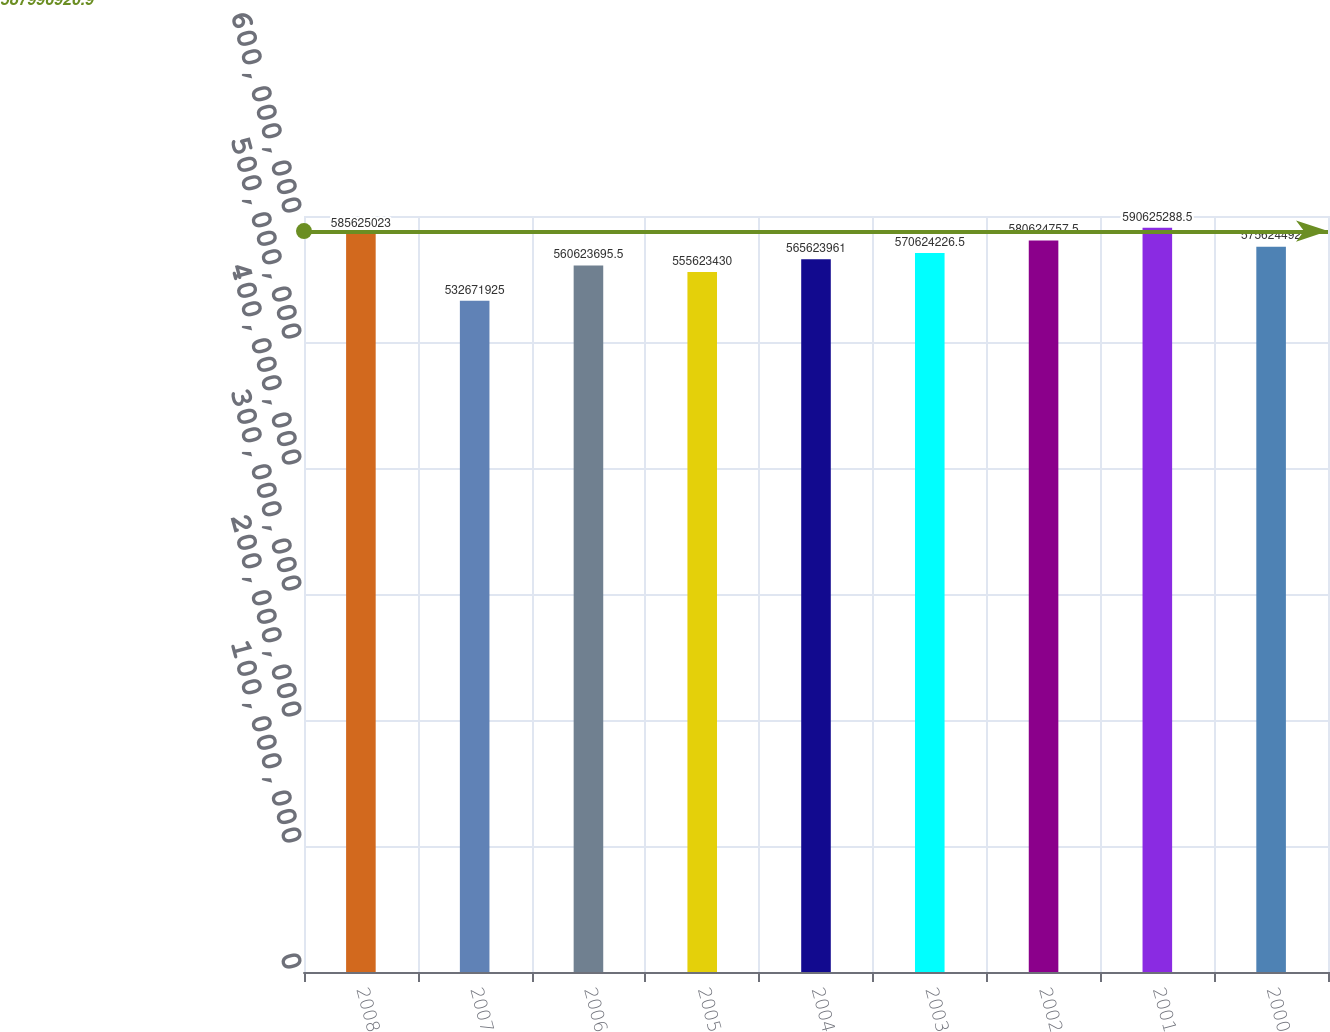Convert chart. <chart><loc_0><loc_0><loc_500><loc_500><bar_chart><fcel>2008<fcel>2007<fcel>2006<fcel>2005<fcel>2004<fcel>2003<fcel>2002<fcel>2001<fcel>2000<nl><fcel>5.85625e+08<fcel>5.32672e+08<fcel>5.60624e+08<fcel>5.55623e+08<fcel>5.65624e+08<fcel>5.70624e+08<fcel>5.80625e+08<fcel>5.90625e+08<fcel>5.75624e+08<nl></chart> 